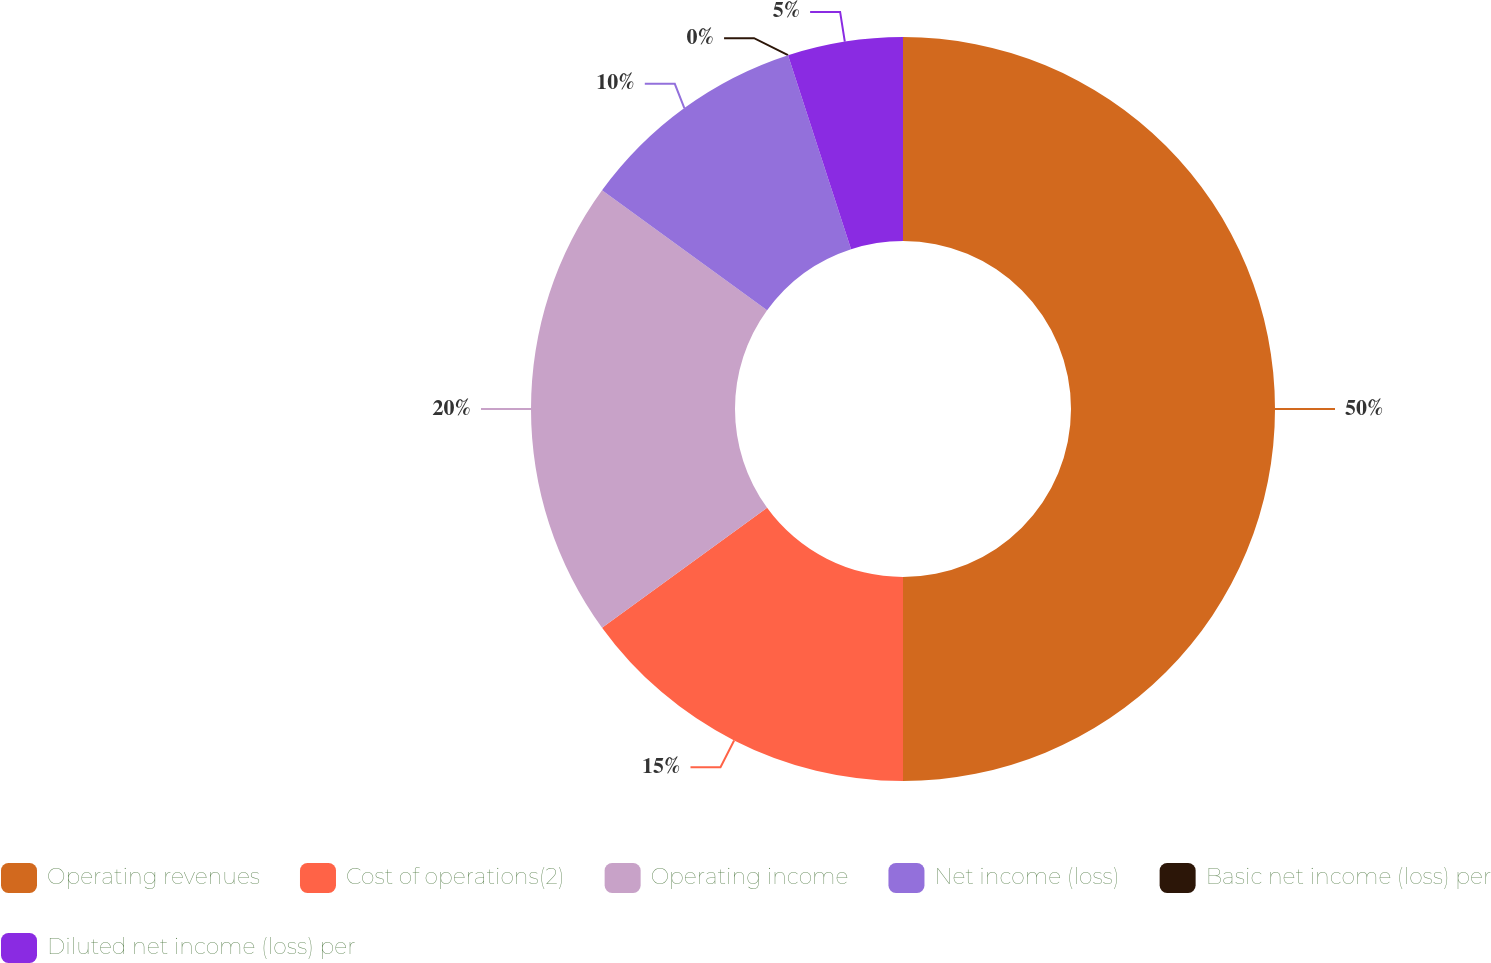<chart> <loc_0><loc_0><loc_500><loc_500><pie_chart><fcel>Operating revenues<fcel>Cost of operations(2)<fcel>Operating income<fcel>Net income (loss)<fcel>Basic net income (loss) per<fcel>Diluted net income (loss) per<nl><fcel>50.0%<fcel>15.0%<fcel>20.0%<fcel>10.0%<fcel>0.0%<fcel>5.0%<nl></chart> 